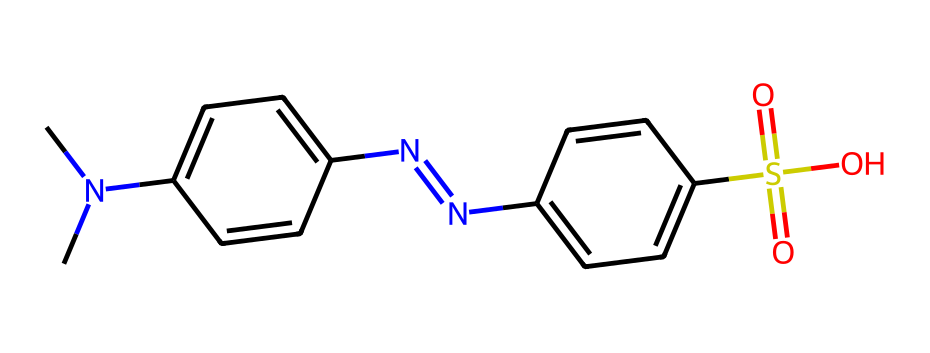What is the molecular formula of Methyl Orange? To find the molecular formula, count the number of each type of atom in the SMILES structure. There are 14 Carbon (C), 15 Hydrogen (H), 2 Nitrogen (N), 2 Sulfur (S), and 4 Oxygen (O) atoms, giving the formula C14H15N3O3S.
Answer: C14H15N3O3S How many aromatic rings are present in the structure? By examining the structure in the SMILES, two distinct aromatic rings can be identified: one connected to the dimethylamino group and the other connected to the sulfonic acid.
Answer: 2 What color does Methyl Orange indicate in acidic conditions? Methyl Orange is known to change color depending on pH; in acidic conditions (pH < 3.1), it typically appears red.
Answer: red Which functional group in Methyl Orange contributes to its acidity? The presence of the sulfonic acid group (–SO3H) is responsible for the acidic character of Methyl Orange. This group can donate protons to the solution, thereby contributing to acidity.
Answer: sulfonic acid How many nitrogen atoms are present in Methyl Orange? By reviewing the SMILES representation, we can see two nitrogen atoms in the azo (N=N) group and one nitrogen in the dimethylamino group, totaling three nitrogen atoms.
Answer: 3 What type of dye is Methyl Orange considered? Methyl Orange is classified as an azo dye due to the presence of the azo linkage (N=N) in its structure.
Answer: azo dye What is the effect of the pH on the color change of Methyl Orange? The pH significantly affects the color due to protonation and deprotonation of the functional groups. In acidic solutions, it appears red, and in neutral to basic solutions, it changes to yellow.
Answer: color change 